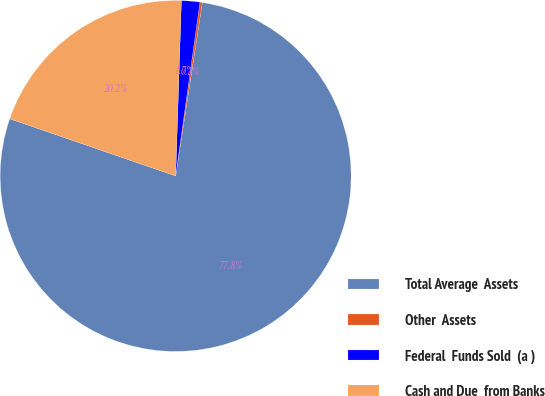Convert chart to OTSL. <chart><loc_0><loc_0><loc_500><loc_500><pie_chart><fcel>Total Average  Assets<fcel>Other  Assets<fcel>Federal  Funds Sold  (a )<fcel>Cash and Due  from Banks<nl><fcel>77.85%<fcel>0.22%<fcel>1.69%<fcel>20.24%<nl></chart> 